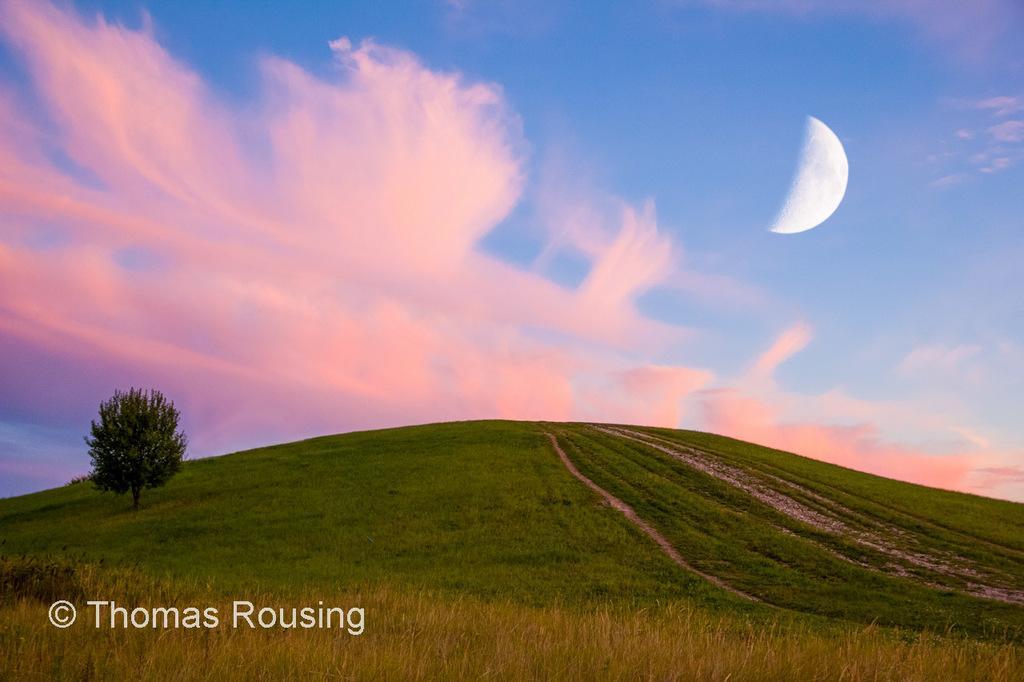Describe this image in one or two sentences. In this image, we can see a grass, tree. Top of the image, there is a sky with moon. At the bottom of the image, we can see a watermark. 